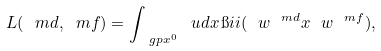<formula> <loc_0><loc_0><loc_500><loc_500>L ( \ m d , \ m f ) = \int _ { \ g p x ^ { 0 } } \ u d x \, \i i i ( \ w ^ { \ m d } x \ w ^ { \ m f } ) ,</formula> 